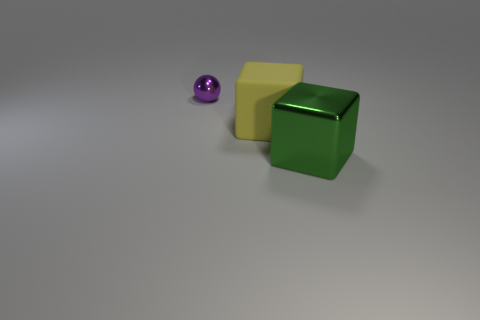Add 1 small purple objects. How many objects exist? 4 Subtract 1 blocks. How many blocks are left? 1 Subtract all yellow cubes. How many cubes are left? 1 Subtract all spheres. How many objects are left? 2 Subtract all small red cylinders. Subtract all yellow rubber blocks. How many objects are left? 2 Add 2 tiny objects. How many tiny objects are left? 3 Add 1 balls. How many balls exist? 2 Subtract 0 purple cylinders. How many objects are left? 3 Subtract all red blocks. Subtract all yellow balls. How many blocks are left? 2 Subtract all purple balls. How many yellow blocks are left? 1 